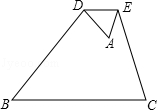First perform reasoning, then finally select the question from the choices in the following format: Answer: xxx.
Question: As shown in the figure, turn △ABC along DE, DE ∥ BC, if \frac ADBD = \frac{1.0}{3.0}, BC = u, then the length of DE is 2.0
 What is the value of the unknown variable u?
Choices:
A: 8.0
B: 21.0
C: 26.0
D: 22.0  
Given that the length of DE is 2.0. Since DE is parallel to BC, we have triangle ADE similar to triangle ABC. Therefore, DE/BC = AD/AB. Given that AD/BD = 1/3 and the length of DE is 2.0, we can find that DE/BC = 2.0/8.0 = 1/4. Therefore, the unknown variable u, which represents the length of BC, is 8.  Therefore, the answer is option A.
Answer:A 